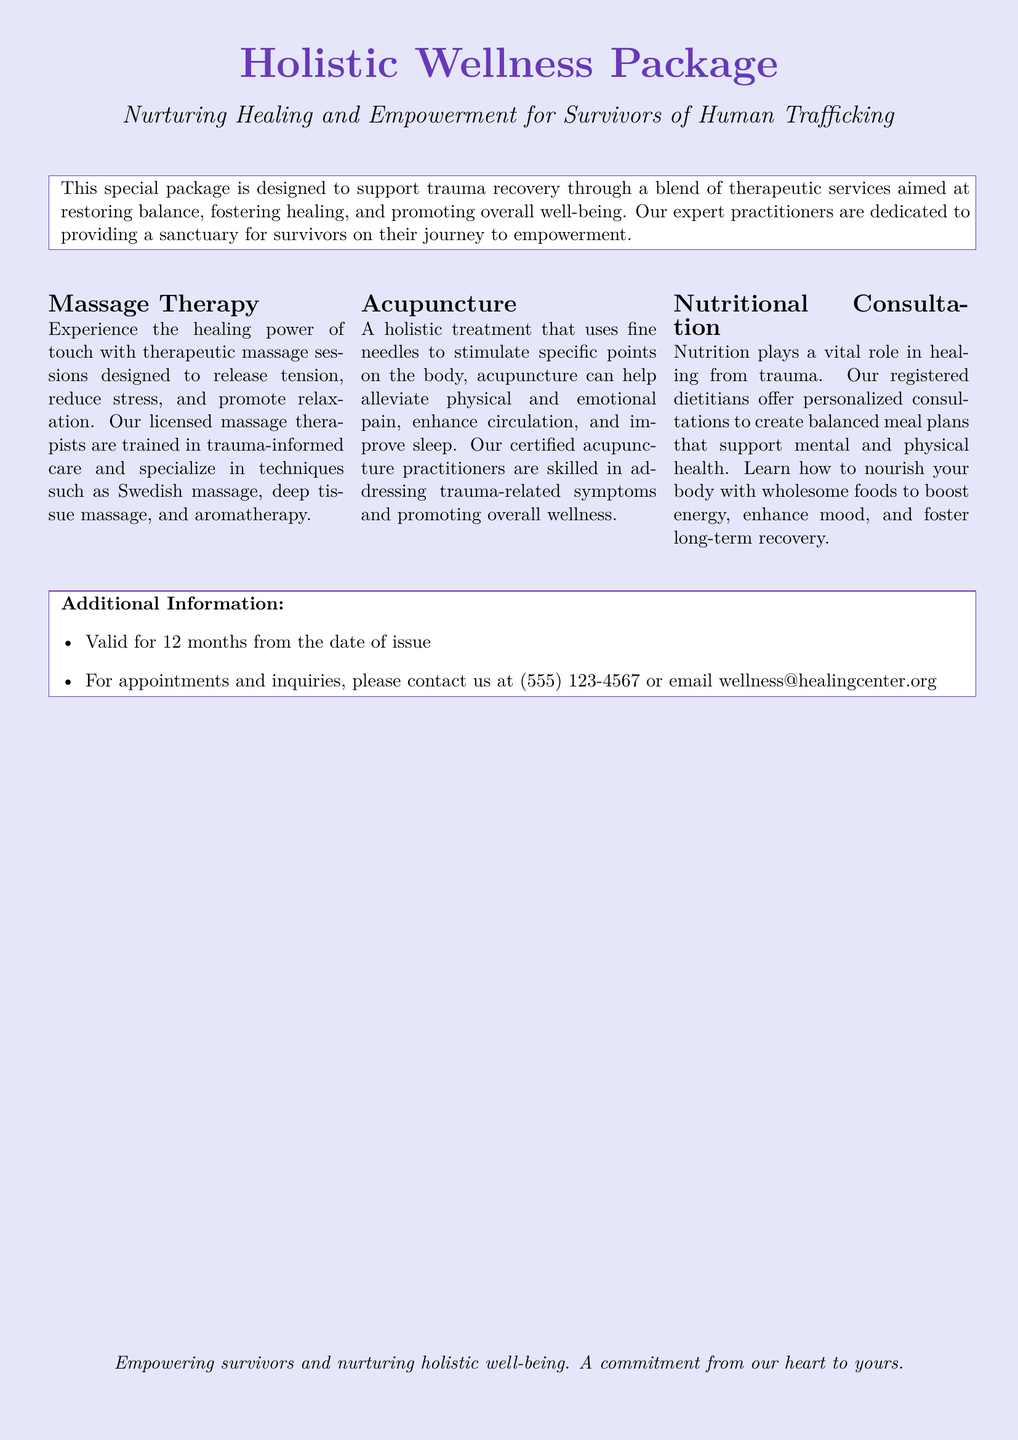What is the title of the package? The title of the package is clearly stated at the top of the document.
Answer: Holistic Wellness Package What services are included in the package? The document lists the services provided in the Holistic Wellness Package.
Answer: Massage Therapy, Acupuncture, Nutritional Consultation Who is the target audience for this package? The document mentions who the package is designed to support.
Answer: Survivors of Human Trafficking How long is the voucher valid? The validity period of the voucher is specified in the additional information section.
Answer: 12 months What is the contact phone number for appointments? The document provides contact information for inquiries and appointments.
Answer: (555) 123-4567 What type of massage techniques are mentioned? The document describes the types of massage techniques offered.
Answer: Swedish massage, deep tissue massage, aromatherapy What does the nutritional consultation aim to create? The purpose of nutritional consultation is stated in the description.
Answer: Balanced meal plans What is the overarching goal of the Holistic Wellness Package? The document outlines the primary aim of the package in the introductory description.
Answer: Nurturing Healing and Empowerment What color is used for the page background? The background color is specified at the top of the document.
Answer: Lavender 